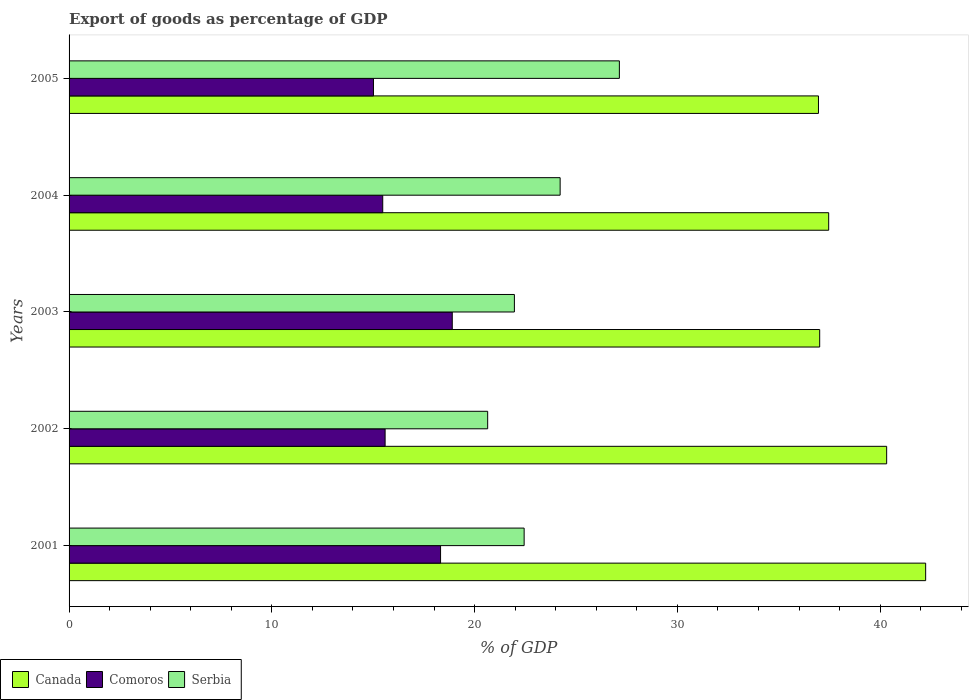How many groups of bars are there?
Ensure brevity in your answer.  5. Are the number of bars per tick equal to the number of legend labels?
Give a very brief answer. Yes. In how many cases, is the number of bars for a given year not equal to the number of legend labels?
Give a very brief answer. 0. What is the export of goods as percentage of GDP in Serbia in 2004?
Offer a very short reply. 24.22. Across all years, what is the maximum export of goods as percentage of GDP in Comoros?
Ensure brevity in your answer.  18.9. Across all years, what is the minimum export of goods as percentage of GDP in Canada?
Offer a terse response. 36.96. In which year was the export of goods as percentage of GDP in Serbia maximum?
Ensure brevity in your answer.  2005. What is the total export of goods as percentage of GDP in Serbia in the graph?
Make the answer very short. 116.41. What is the difference between the export of goods as percentage of GDP in Serbia in 2002 and that in 2005?
Make the answer very short. -6.5. What is the difference between the export of goods as percentage of GDP in Comoros in 2004 and the export of goods as percentage of GDP in Serbia in 2002?
Offer a terse response. -5.18. What is the average export of goods as percentage of GDP in Serbia per year?
Make the answer very short. 23.28. In the year 2005, what is the difference between the export of goods as percentage of GDP in Serbia and export of goods as percentage of GDP in Canada?
Make the answer very short. -9.82. What is the ratio of the export of goods as percentage of GDP in Canada in 2001 to that in 2003?
Ensure brevity in your answer.  1.14. Is the export of goods as percentage of GDP in Serbia in 2001 less than that in 2003?
Your response must be concise. No. Is the difference between the export of goods as percentage of GDP in Serbia in 2003 and 2004 greater than the difference between the export of goods as percentage of GDP in Canada in 2003 and 2004?
Your answer should be very brief. No. What is the difference between the highest and the second highest export of goods as percentage of GDP in Canada?
Your response must be concise. 1.92. What is the difference between the highest and the lowest export of goods as percentage of GDP in Comoros?
Give a very brief answer. 3.89. What does the 2nd bar from the top in 2003 represents?
Your response must be concise. Comoros. What does the 3rd bar from the bottom in 2004 represents?
Your response must be concise. Serbia. Is it the case that in every year, the sum of the export of goods as percentage of GDP in Serbia and export of goods as percentage of GDP in Comoros is greater than the export of goods as percentage of GDP in Canada?
Make the answer very short. No. How many bars are there?
Your answer should be very brief. 15. Are all the bars in the graph horizontal?
Give a very brief answer. Yes. How many years are there in the graph?
Your response must be concise. 5. What is the difference between two consecutive major ticks on the X-axis?
Offer a terse response. 10. Does the graph contain any zero values?
Your answer should be compact. No. Does the graph contain grids?
Offer a very short reply. No. How many legend labels are there?
Offer a very short reply. 3. How are the legend labels stacked?
Your answer should be very brief. Horizontal. What is the title of the graph?
Ensure brevity in your answer.  Export of goods as percentage of GDP. What is the label or title of the X-axis?
Offer a very short reply. % of GDP. What is the label or title of the Y-axis?
Keep it short and to the point. Years. What is the % of GDP of Canada in 2001?
Provide a succinct answer. 42.25. What is the % of GDP in Comoros in 2001?
Make the answer very short. 18.32. What is the % of GDP in Serbia in 2001?
Your response must be concise. 22.44. What is the % of GDP of Canada in 2002?
Make the answer very short. 40.32. What is the % of GDP of Comoros in 2002?
Provide a short and direct response. 15.59. What is the % of GDP of Serbia in 2002?
Provide a succinct answer. 20.65. What is the % of GDP of Canada in 2003?
Keep it short and to the point. 37.02. What is the % of GDP of Comoros in 2003?
Your response must be concise. 18.9. What is the % of GDP of Serbia in 2003?
Offer a terse response. 21.96. What is the % of GDP of Canada in 2004?
Make the answer very short. 37.46. What is the % of GDP in Comoros in 2004?
Offer a very short reply. 15.47. What is the % of GDP in Serbia in 2004?
Your response must be concise. 24.22. What is the % of GDP in Canada in 2005?
Provide a succinct answer. 36.96. What is the % of GDP of Comoros in 2005?
Offer a very short reply. 15.01. What is the % of GDP in Serbia in 2005?
Ensure brevity in your answer.  27.14. Across all years, what is the maximum % of GDP in Canada?
Your answer should be very brief. 42.25. Across all years, what is the maximum % of GDP in Comoros?
Make the answer very short. 18.9. Across all years, what is the maximum % of GDP of Serbia?
Your answer should be very brief. 27.14. Across all years, what is the minimum % of GDP of Canada?
Your answer should be compact. 36.96. Across all years, what is the minimum % of GDP in Comoros?
Your answer should be compact. 15.01. Across all years, what is the minimum % of GDP in Serbia?
Your response must be concise. 20.65. What is the total % of GDP in Canada in the graph?
Provide a succinct answer. 194.01. What is the total % of GDP in Comoros in the graph?
Give a very brief answer. 83.29. What is the total % of GDP of Serbia in the graph?
Your response must be concise. 116.41. What is the difference between the % of GDP of Canada in 2001 and that in 2002?
Offer a terse response. 1.92. What is the difference between the % of GDP of Comoros in 2001 and that in 2002?
Make the answer very short. 2.73. What is the difference between the % of GDP in Serbia in 2001 and that in 2002?
Give a very brief answer. 1.8. What is the difference between the % of GDP in Canada in 2001 and that in 2003?
Ensure brevity in your answer.  5.23. What is the difference between the % of GDP of Comoros in 2001 and that in 2003?
Your answer should be compact. -0.58. What is the difference between the % of GDP in Serbia in 2001 and that in 2003?
Make the answer very short. 0.48. What is the difference between the % of GDP of Canada in 2001 and that in 2004?
Offer a very short reply. 4.78. What is the difference between the % of GDP of Comoros in 2001 and that in 2004?
Offer a terse response. 2.85. What is the difference between the % of GDP in Serbia in 2001 and that in 2004?
Offer a terse response. -1.78. What is the difference between the % of GDP of Canada in 2001 and that in 2005?
Your response must be concise. 5.29. What is the difference between the % of GDP in Comoros in 2001 and that in 2005?
Your answer should be very brief. 3.31. What is the difference between the % of GDP in Serbia in 2001 and that in 2005?
Your answer should be compact. -4.7. What is the difference between the % of GDP of Canada in 2002 and that in 2003?
Offer a very short reply. 3.3. What is the difference between the % of GDP of Comoros in 2002 and that in 2003?
Keep it short and to the point. -3.31. What is the difference between the % of GDP of Serbia in 2002 and that in 2003?
Your answer should be compact. -1.32. What is the difference between the % of GDP of Canada in 2002 and that in 2004?
Provide a succinct answer. 2.86. What is the difference between the % of GDP of Comoros in 2002 and that in 2004?
Make the answer very short. 0.12. What is the difference between the % of GDP of Serbia in 2002 and that in 2004?
Your response must be concise. -3.57. What is the difference between the % of GDP in Canada in 2002 and that in 2005?
Provide a succinct answer. 3.36. What is the difference between the % of GDP of Comoros in 2002 and that in 2005?
Ensure brevity in your answer.  0.57. What is the difference between the % of GDP in Serbia in 2002 and that in 2005?
Give a very brief answer. -6.5. What is the difference between the % of GDP in Canada in 2003 and that in 2004?
Give a very brief answer. -0.44. What is the difference between the % of GDP of Comoros in 2003 and that in 2004?
Your answer should be compact. 3.43. What is the difference between the % of GDP of Serbia in 2003 and that in 2004?
Keep it short and to the point. -2.26. What is the difference between the % of GDP of Comoros in 2003 and that in 2005?
Make the answer very short. 3.89. What is the difference between the % of GDP in Serbia in 2003 and that in 2005?
Your response must be concise. -5.18. What is the difference between the % of GDP of Canada in 2004 and that in 2005?
Ensure brevity in your answer.  0.5. What is the difference between the % of GDP of Comoros in 2004 and that in 2005?
Make the answer very short. 0.46. What is the difference between the % of GDP in Serbia in 2004 and that in 2005?
Provide a short and direct response. -2.92. What is the difference between the % of GDP in Canada in 2001 and the % of GDP in Comoros in 2002?
Your response must be concise. 26.66. What is the difference between the % of GDP of Canada in 2001 and the % of GDP of Serbia in 2002?
Ensure brevity in your answer.  21.6. What is the difference between the % of GDP of Comoros in 2001 and the % of GDP of Serbia in 2002?
Your response must be concise. -2.32. What is the difference between the % of GDP in Canada in 2001 and the % of GDP in Comoros in 2003?
Keep it short and to the point. 23.35. What is the difference between the % of GDP in Canada in 2001 and the % of GDP in Serbia in 2003?
Give a very brief answer. 20.28. What is the difference between the % of GDP in Comoros in 2001 and the % of GDP in Serbia in 2003?
Your answer should be very brief. -3.64. What is the difference between the % of GDP in Canada in 2001 and the % of GDP in Comoros in 2004?
Provide a short and direct response. 26.78. What is the difference between the % of GDP in Canada in 2001 and the % of GDP in Serbia in 2004?
Make the answer very short. 18.03. What is the difference between the % of GDP in Comoros in 2001 and the % of GDP in Serbia in 2004?
Ensure brevity in your answer.  -5.9. What is the difference between the % of GDP in Canada in 2001 and the % of GDP in Comoros in 2005?
Keep it short and to the point. 27.23. What is the difference between the % of GDP in Canada in 2001 and the % of GDP in Serbia in 2005?
Provide a succinct answer. 15.11. What is the difference between the % of GDP in Comoros in 2001 and the % of GDP in Serbia in 2005?
Make the answer very short. -8.82. What is the difference between the % of GDP of Canada in 2002 and the % of GDP of Comoros in 2003?
Your answer should be very brief. 21.42. What is the difference between the % of GDP in Canada in 2002 and the % of GDP in Serbia in 2003?
Offer a terse response. 18.36. What is the difference between the % of GDP of Comoros in 2002 and the % of GDP of Serbia in 2003?
Ensure brevity in your answer.  -6.38. What is the difference between the % of GDP in Canada in 2002 and the % of GDP in Comoros in 2004?
Offer a terse response. 24.85. What is the difference between the % of GDP of Canada in 2002 and the % of GDP of Serbia in 2004?
Your response must be concise. 16.1. What is the difference between the % of GDP in Comoros in 2002 and the % of GDP in Serbia in 2004?
Make the answer very short. -8.63. What is the difference between the % of GDP of Canada in 2002 and the % of GDP of Comoros in 2005?
Your answer should be very brief. 25.31. What is the difference between the % of GDP in Canada in 2002 and the % of GDP in Serbia in 2005?
Keep it short and to the point. 13.18. What is the difference between the % of GDP in Comoros in 2002 and the % of GDP in Serbia in 2005?
Keep it short and to the point. -11.55. What is the difference between the % of GDP of Canada in 2003 and the % of GDP of Comoros in 2004?
Offer a very short reply. 21.55. What is the difference between the % of GDP in Canada in 2003 and the % of GDP in Serbia in 2004?
Keep it short and to the point. 12.8. What is the difference between the % of GDP in Comoros in 2003 and the % of GDP in Serbia in 2004?
Give a very brief answer. -5.32. What is the difference between the % of GDP in Canada in 2003 and the % of GDP in Comoros in 2005?
Provide a short and direct response. 22.01. What is the difference between the % of GDP of Canada in 2003 and the % of GDP of Serbia in 2005?
Provide a succinct answer. 9.88. What is the difference between the % of GDP of Comoros in 2003 and the % of GDP of Serbia in 2005?
Give a very brief answer. -8.24. What is the difference between the % of GDP in Canada in 2004 and the % of GDP in Comoros in 2005?
Offer a very short reply. 22.45. What is the difference between the % of GDP in Canada in 2004 and the % of GDP in Serbia in 2005?
Your answer should be compact. 10.32. What is the difference between the % of GDP of Comoros in 2004 and the % of GDP of Serbia in 2005?
Provide a short and direct response. -11.67. What is the average % of GDP of Canada per year?
Give a very brief answer. 38.8. What is the average % of GDP in Comoros per year?
Provide a short and direct response. 16.66. What is the average % of GDP in Serbia per year?
Make the answer very short. 23.28. In the year 2001, what is the difference between the % of GDP in Canada and % of GDP in Comoros?
Make the answer very short. 23.92. In the year 2001, what is the difference between the % of GDP of Canada and % of GDP of Serbia?
Provide a succinct answer. 19.8. In the year 2001, what is the difference between the % of GDP in Comoros and % of GDP in Serbia?
Your answer should be very brief. -4.12. In the year 2002, what is the difference between the % of GDP of Canada and % of GDP of Comoros?
Your answer should be compact. 24.74. In the year 2002, what is the difference between the % of GDP of Canada and % of GDP of Serbia?
Provide a succinct answer. 19.68. In the year 2002, what is the difference between the % of GDP of Comoros and % of GDP of Serbia?
Ensure brevity in your answer.  -5.06. In the year 2003, what is the difference between the % of GDP in Canada and % of GDP in Comoros?
Your response must be concise. 18.12. In the year 2003, what is the difference between the % of GDP in Canada and % of GDP in Serbia?
Offer a terse response. 15.06. In the year 2003, what is the difference between the % of GDP of Comoros and % of GDP of Serbia?
Keep it short and to the point. -3.06. In the year 2004, what is the difference between the % of GDP of Canada and % of GDP of Comoros?
Provide a succinct answer. 21.99. In the year 2004, what is the difference between the % of GDP of Canada and % of GDP of Serbia?
Your response must be concise. 13.24. In the year 2004, what is the difference between the % of GDP of Comoros and % of GDP of Serbia?
Provide a short and direct response. -8.75. In the year 2005, what is the difference between the % of GDP of Canada and % of GDP of Comoros?
Keep it short and to the point. 21.95. In the year 2005, what is the difference between the % of GDP in Canada and % of GDP in Serbia?
Make the answer very short. 9.82. In the year 2005, what is the difference between the % of GDP in Comoros and % of GDP in Serbia?
Ensure brevity in your answer.  -12.13. What is the ratio of the % of GDP of Canada in 2001 to that in 2002?
Offer a terse response. 1.05. What is the ratio of the % of GDP of Comoros in 2001 to that in 2002?
Your answer should be very brief. 1.18. What is the ratio of the % of GDP of Serbia in 2001 to that in 2002?
Make the answer very short. 1.09. What is the ratio of the % of GDP in Canada in 2001 to that in 2003?
Offer a terse response. 1.14. What is the ratio of the % of GDP in Comoros in 2001 to that in 2003?
Provide a succinct answer. 0.97. What is the ratio of the % of GDP of Serbia in 2001 to that in 2003?
Offer a terse response. 1.02. What is the ratio of the % of GDP of Canada in 2001 to that in 2004?
Your response must be concise. 1.13. What is the ratio of the % of GDP in Comoros in 2001 to that in 2004?
Your response must be concise. 1.18. What is the ratio of the % of GDP of Serbia in 2001 to that in 2004?
Your answer should be compact. 0.93. What is the ratio of the % of GDP in Canada in 2001 to that in 2005?
Provide a short and direct response. 1.14. What is the ratio of the % of GDP in Comoros in 2001 to that in 2005?
Give a very brief answer. 1.22. What is the ratio of the % of GDP of Serbia in 2001 to that in 2005?
Provide a short and direct response. 0.83. What is the ratio of the % of GDP in Canada in 2002 to that in 2003?
Provide a short and direct response. 1.09. What is the ratio of the % of GDP of Comoros in 2002 to that in 2003?
Your answer should be compact. 0.82. What is the ratio of the % of GDP in Serbia in 2002 to that in 2003?
Offer a terse response. 0.94. What is the ratio of the % of GDP in Canada in 2002 to that in 2004?
Offer a terse response. 1.08. What is the ratio of the % of GDP of Comoros in 2002 to that in 2004?
Provide a short and direct response. 1.01. What is the ratio of the % of GDP of Serbia in 2002 to that in 2004?
Offer a very short reply. 0.85. What is the ratio of the % of GDP of Canada in 2002 to that in 2005?
Offer a very short reply. 1.09. What is the ratio of the % of GDP of Comoros in 2002 to that in 2005?
Provide a short and direct response. 1.04. What is the ratio of the % of GDP of Serbia in 2002 to that in 2005?
Give a very brief answer. 0.76. What is the ratio of the % of GDP of Canada in 2003 to that in 2004?
Make the answer very short. 0.99. What is the ratio of the % of GDP in Comoros in 2003 to that in 2004?
Your answer should be very brief. 1.22. What is the ratio of the % of GDP of Serbia in 2003 to that in 2004?
Keep it short and to the point. 0.91. What is the ratio of the % of GDP of Comoros in 2003 to that in 2005?
Make the answer very short. 1.26. What is the ratio of the % of GDP in Serbia in 2003 to that in 2005?
Make the answer very short. 0.81. What is the ratio of the % of GDP of Canada in 2004 to that in 2005?
Make the answer very short. 1.01. What is the ratio of the % of GDP of Comoros in 2004 to that in 2005?
Offer a terse response. 1.03. What is the ratio of the % of GDP in Serbia in 2004 to that in 2005?
Offer a terse response. 0.89. What is the difference between the highest and the second highest % of GDP in Canada?
Offer a terse response. 1.92. What is the difference between the highest and the second highest % of GDP of Comoros?
Provide a short and direct response. 0.58. What is the difference between the highest and the second highest % of GDP of Serbia?
Make the answer very short. 2.92. What is the difference between the highest and the lowest % of GDP in Canada?
Keep it short and to the point. 5.29. What is the difference between the highest and the lowest % of GDP in Comoros?
Ensure brevity in your answer.  3.89. What is the difference between the highest and the lowest % of GDP of Serbia?
Your answer should be very brief. 6.5. 